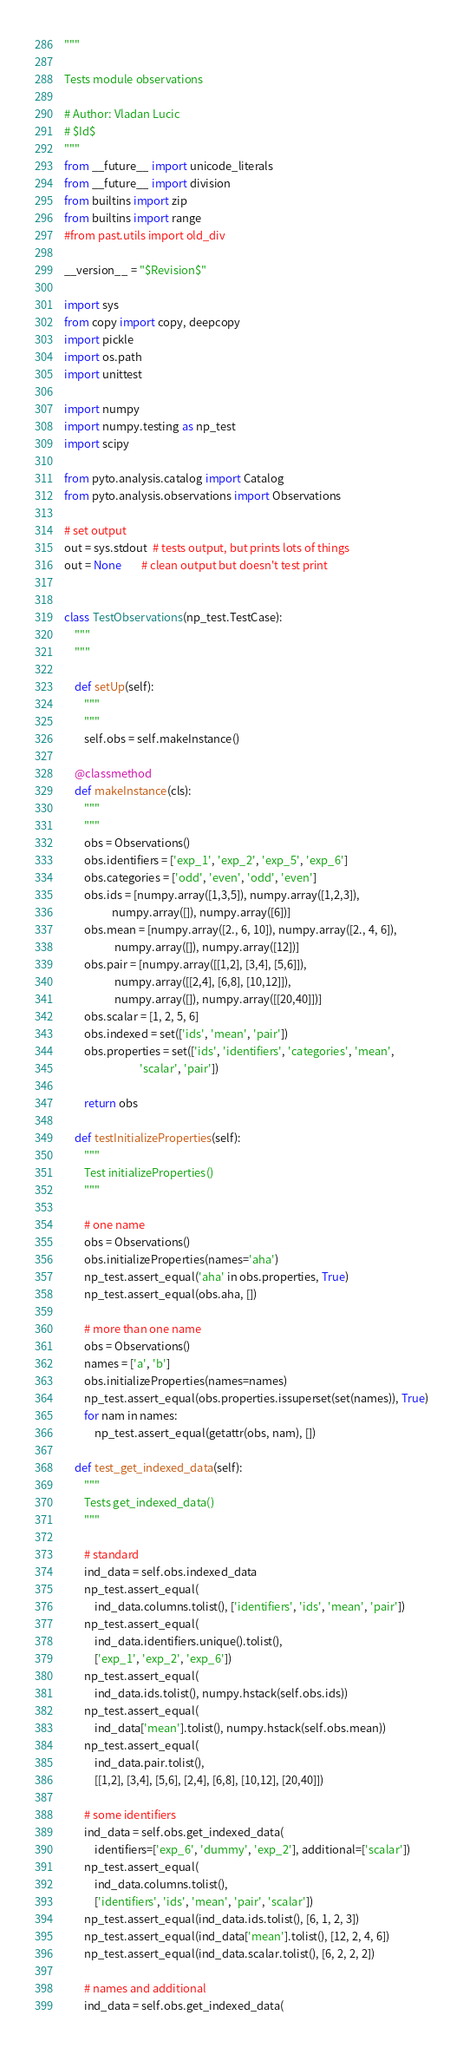<code> <loc_0><loc_0><loc_500><loc_500><_Python_>"""

Tests module observations
 
# Author: Vladan Lucic
# $Id$
"""
from __future__ import unicode_literals
from __future__ import division
from builtins import zip
from builtins import range
#from past.utils import old_div

__version__ = "$Revision$"

import sys
from copy import copy, deepcopy
import pickle
import os.path
import unittest

import numpy
import numpy.testing as np_test 
import scipy

from pyto.analysis.catalog import Catalog
from pyto.analysis.observations import Observations

# set output
out = sys.stdout  # tests output, but prints lots of things 
out = None        # clean output but doesn't test print


class TestObservations(np_test.TestCase):
    """
    """

    def setUp(self):
        """
        """
        self.obs = self.makeInstance()
        
    @classmethod
    def makeInstance(cls):
        """
        """
        obs = Observations()
        obs.identifiers = ['exp_1', 'exp_2', 'exp_5', 'exp_6']
        obs.categories = ['odd', 'even', 'odd', 'even']
        obs.ids = [numpy.array([1,3,5]), numpy.array([1,2,3]),
                   numpy.array([]), numpy.array([6])]
        obs.mean = [numpy.array([2., 6, 10]), numpy.array([2., 4, 6]),
                    numpy.array([]), numpy.array([12])]
        obs.pair = [numpy.array([[1,2], [3,4], [5,6]]), 
                    numpy.array([[2,4], [6,8], [10,12]]), 
                    numpy.array([]), numpy.array([[20,40]])]
        obs.scalar = [1, 2, 5, 6]
        obs.indexed = set(['ids', 'mean', 'pair'])
        obs.properties = set(['ids', 'identifiers', 'categories', 'mean', 
                              'scalar', 'pair'])

        return obs

    def testInitializeProperties(self):
        """
        Test initializeProperties()
        """

        # one name
        obs = Observations()
        obs.initializeProperties(names='aha')
        np_test.assert_equal('aha' in obs.properties, True)
        np_test.assert_equal(obs.aha, [])

        # more than one name
        obs = Observations()
        names = ['a', 'b']
        obs.initializeProperties(names=names)
        np_test.assert_equal(obs.properties.issuperset(set(names)), True)
        for nam in names:
            np_test.assert_equal(getattr(obs, nam), [])

    def test_get_indexed_data(self):
        """
        Tests get_indexed_data()
        """

        # standard
        ind_data = self.obs.indexed_data
        np_test.assert_equal(
            ind_data.columns.tolist(), ['identifiers', 'ids', 'mean', 'pair'])
        np_test.assert_equal(
            ind_data.identifiers.unique().tolist(),
            ['exp_1', 'exp_2', 'exp_6'])
        np_test.assert_equal(
            ind_data.ids.tolist(), numpy.hstack(self.obs.ids))
        np_test.assert_equal(
            ind_data['mean'].tolist(), numpy.hstack(self.obs.mean))
        np_test.assert_equal(
            ind_data.pair.tolist(),
            [[1,2], [3,4], [5,6], [2,4], [6,8], [10,12], [20,40]])

        # some identifiers
        ind_data = self.obs.get_indexed_data(
            identifiers=['exp_6', 'dummy', 'exp_2'], additional=['scalar'])
        np_test.assert_equal(
            ind_data.columns.tolist(),
            ['identifiers', 'ids', 'mean', 'pair', 'scalar'])
        np_test.assert_equal(ind_data.ids.tolist(), [6, 1, 2, 3])
        np_test.assert_equal(ind_data['mean'].tolist(), [12, 2, 4, 6])
        np_test.assert_equal(ind_data.scalar.tolist(), [6, 2, 2, 2])

        # names and additional
        ind_data = self.obs.get_indexed_data(</code> 